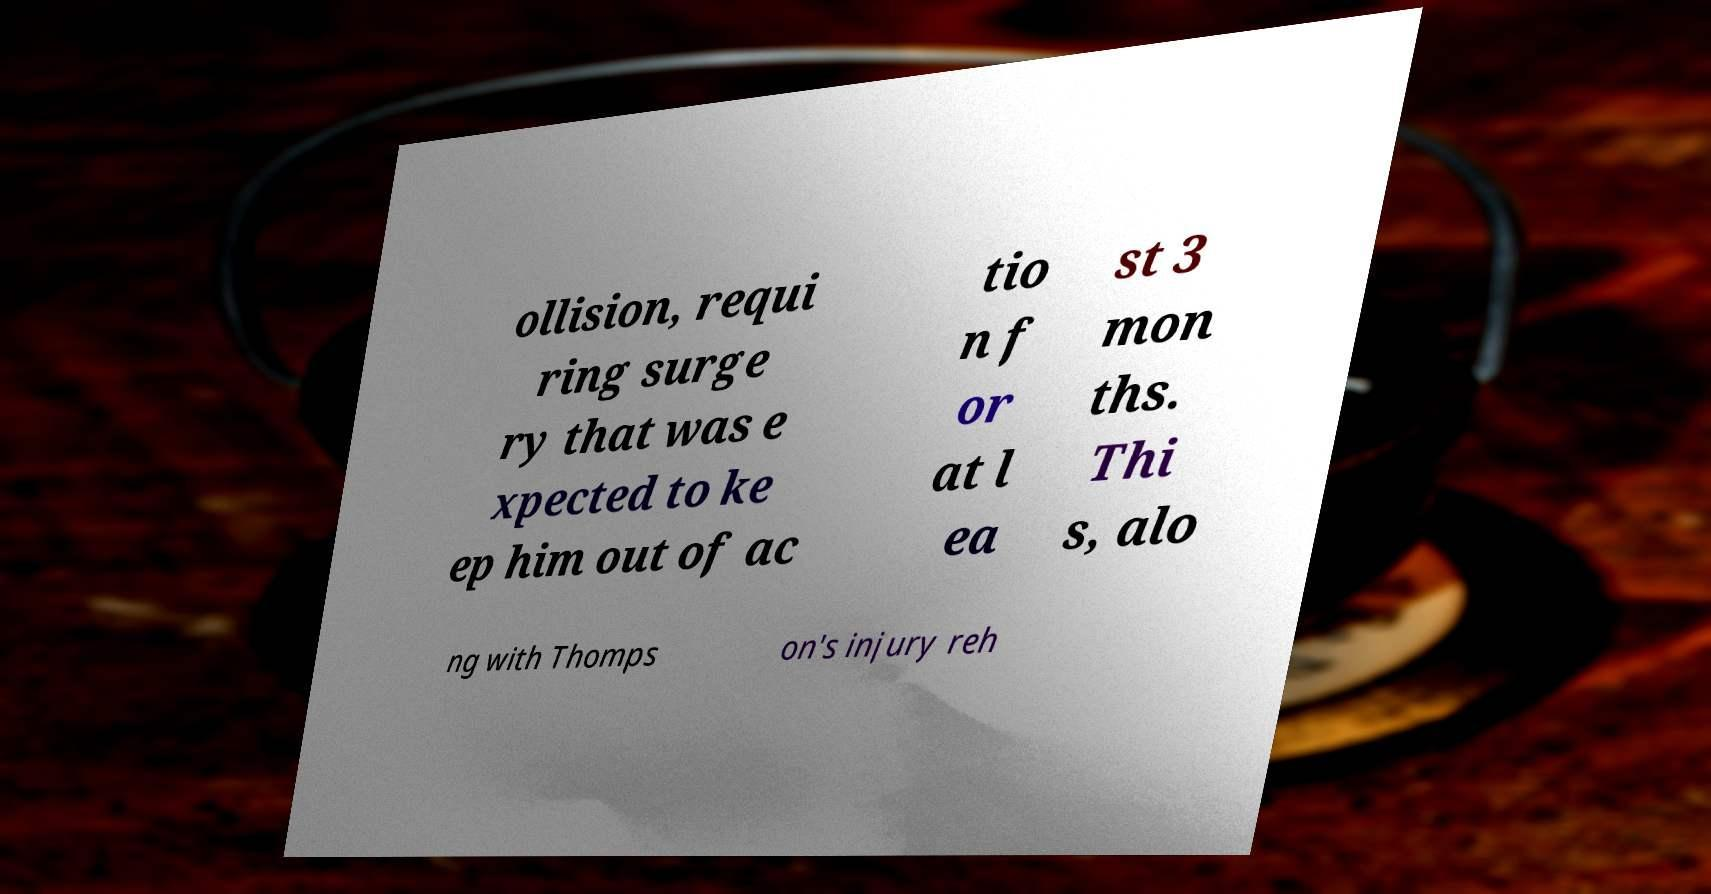Could you extract and type out the text from this image? ollision, requi ring surge ry that was e xpected to ke ep him out of ac tio n f or at l ea st 3 mon ths. Thi s, alo ng with Thomps on's injury reh 